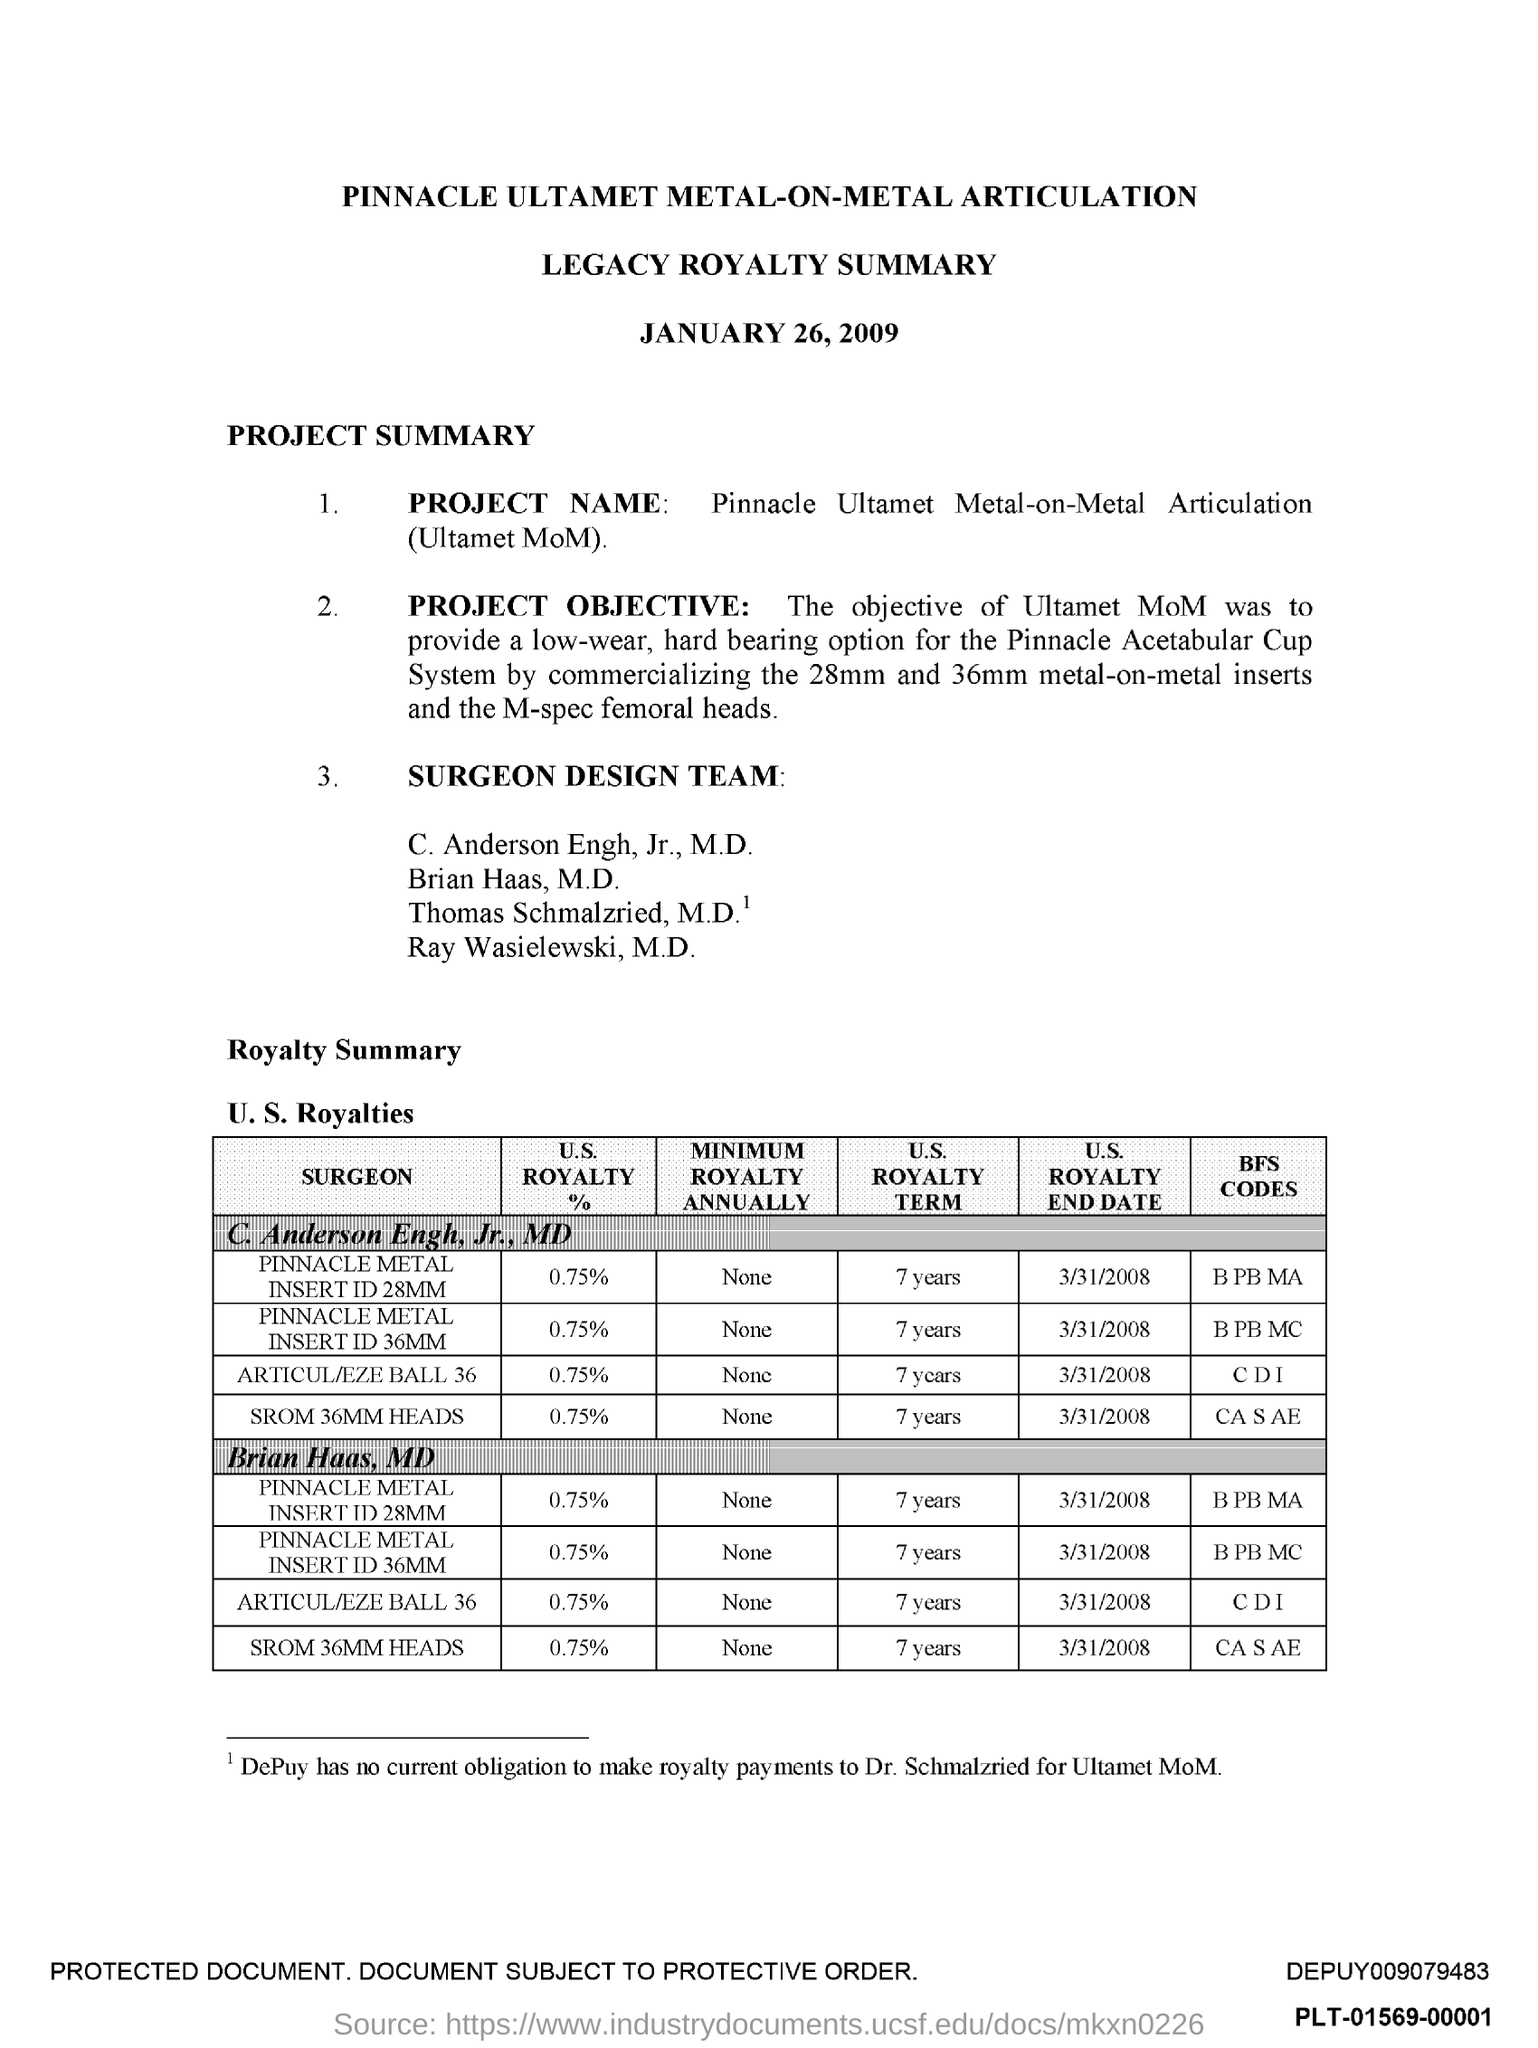What is the title of the document?
Your response must be concise. Pinnacle ultamet metal-on-metal articulation. What is the second title in this document?
Give a very brief answer. Legacy Royalty Summary. 